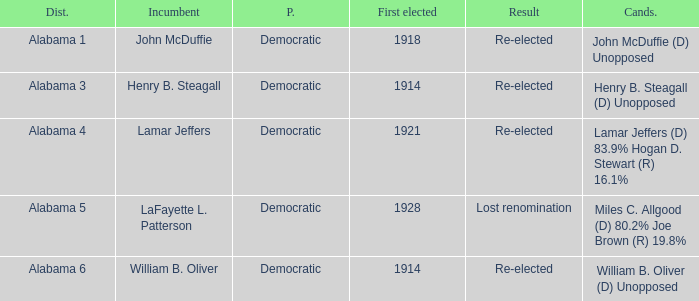How many in lost renomination results were elected first? 1928.0. 